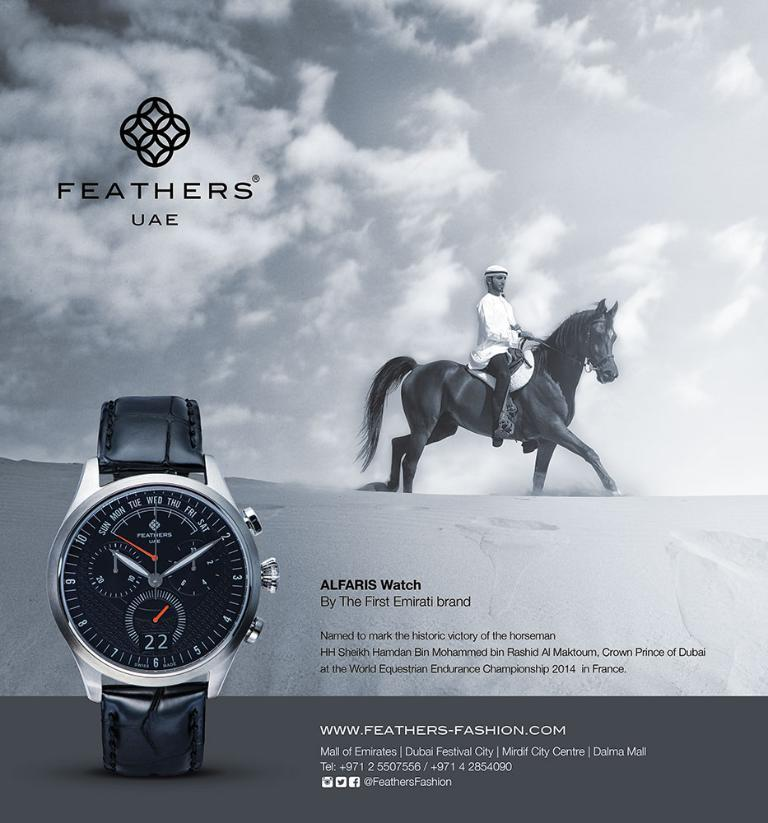<image>
Provide a brief description of the given image. A black and white ad for Feathers UAE displays a Alfaris Watch and a man riding a horse. 